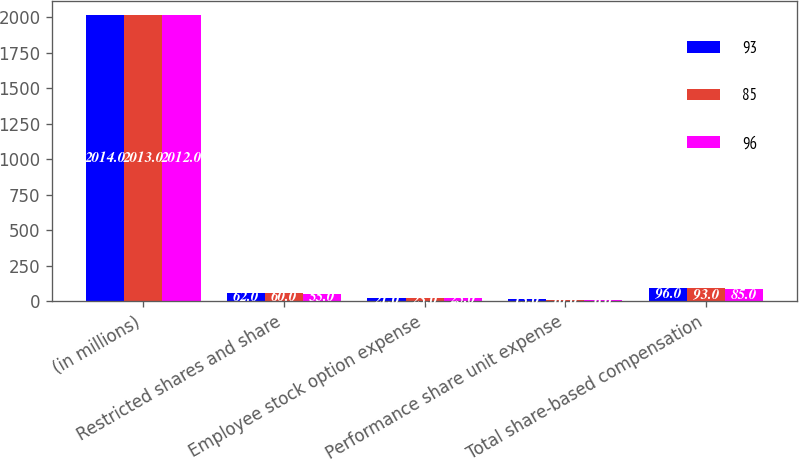Convert chart. <chart><loc_0><loc_0><loc_500><loc_500><stacked_bar_chart><ecel><fcel>(in millions)<fcel>Restricted shares and share<fcel>Employee stock option expense<fcel>Performance share unit expense<fcel>Total share-based compensation<nl><fcel>93<fcel>2014<fcel>62<fcel>21<fcel>13<fcel>96<nl><fcel>85<fcel>2013<fcel>60<fcel>23<fcel>10<fcel>93<nl><fcel>96<fcel>2012<fcel>55<fcel>25<fcel>6<fcel>85<nl></chart> 